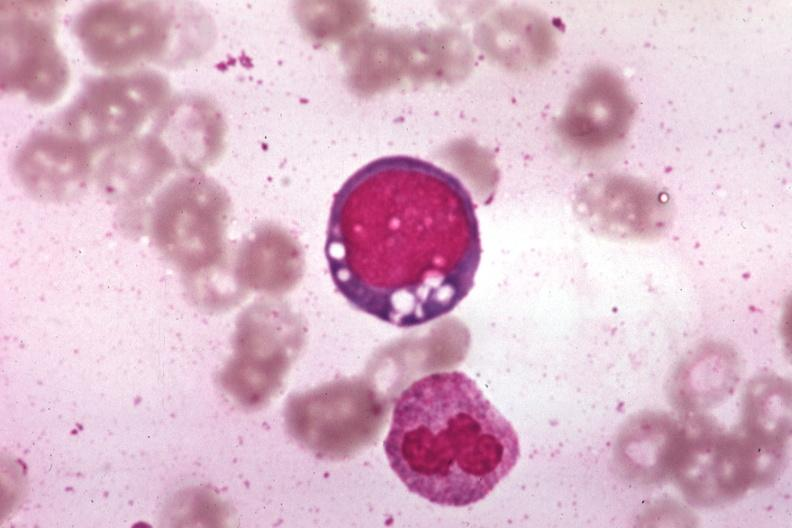s bone marrow present?
Answer the question using a single word or phrase. Yes 